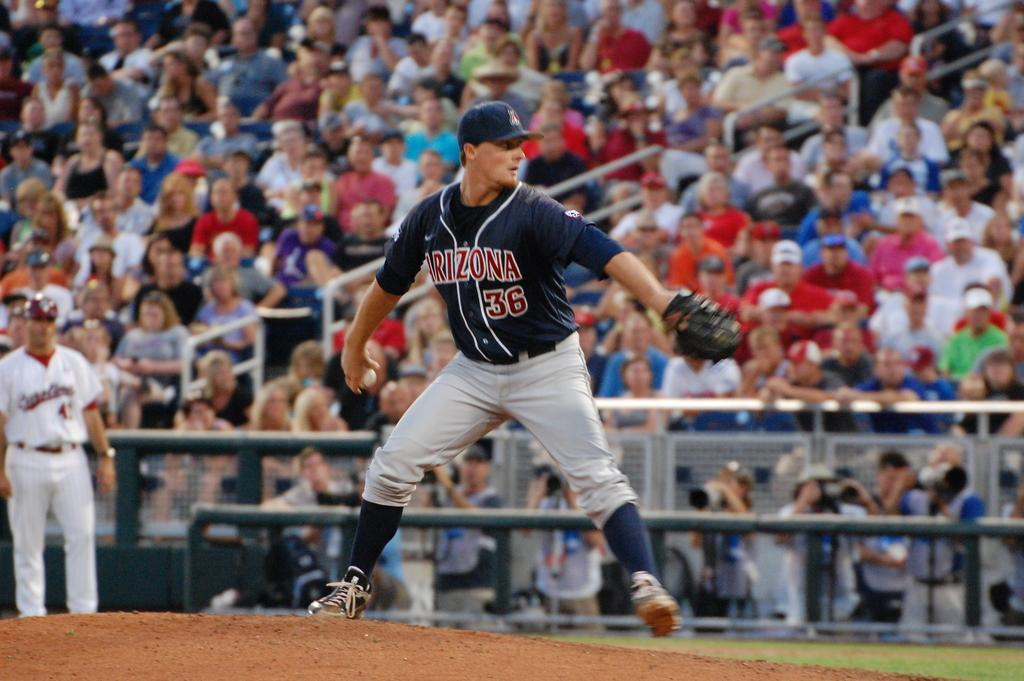<image>
Give a short and clear explanation of the subsequent image. An Arizona baseball player about to make a pitch in front of a crowd. 